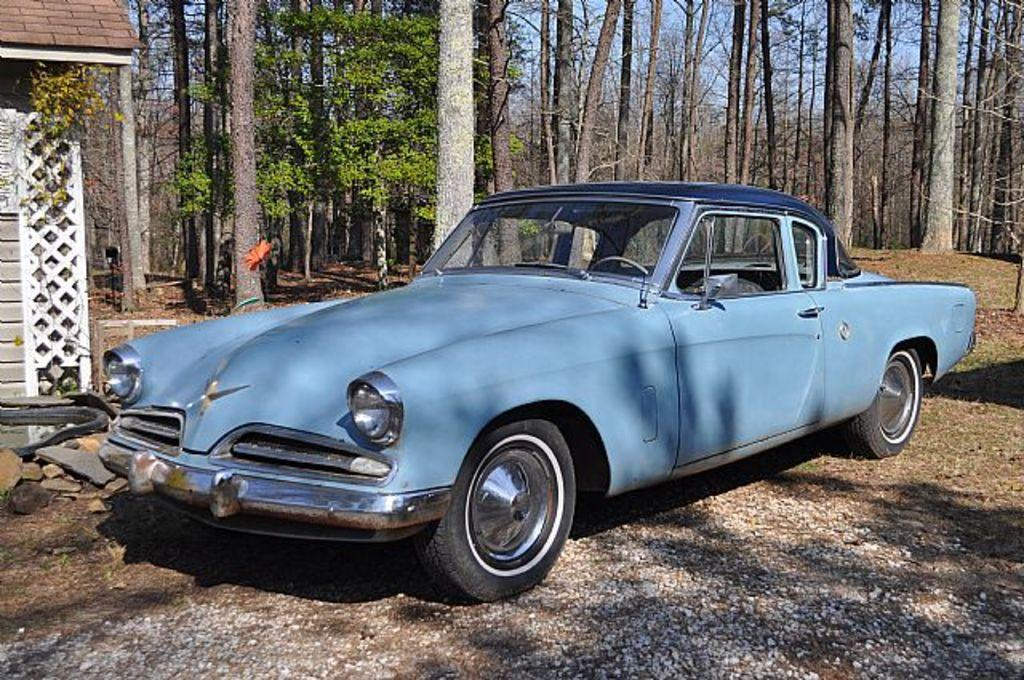What is the main subject of the image? The main subject of the image is a car. Where is the car located in the image? The car is on the road in the image. What can be seen in the background of the image? Trees and the sky are visible in the background of the image. What type of observation can be made about the car's operation in the image? The image does not provide any information about the car's operation, so it is not possible to make such an observation. Can you see any bubbles in the image? There are no bubbles present in the image. 